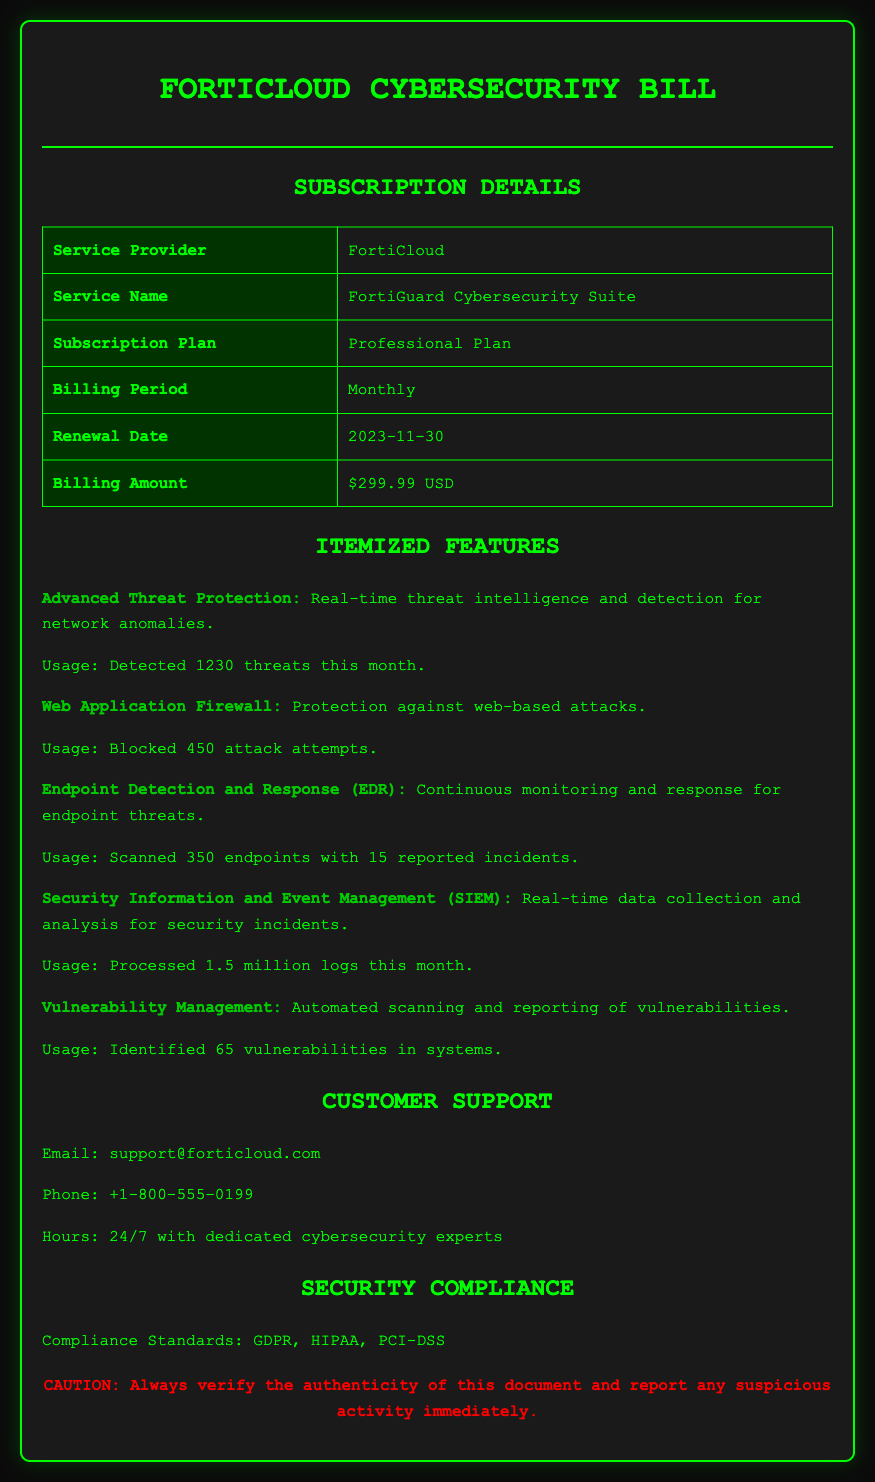What is the service provider? The document clearly states that the service provider is FortiCloud.
Answer: FortiCloud What is the subscription plan? The subscription plan is specified in the document as the Professional Plan.
Answer: Professional Plan When is the renewal date? The renewal date for the subscription is mentioned in the document as November 30, 2023.
Answer: 2023-11-30 How much is the monthly billing amount? The monthly billing amount is listed in the document as $299.99 USD.
Answer: $299.99 USD How many threats were detected this month? The document indicates that 1230 threats were detected within the month under the Advanced Threat Protection feature.
Answer: 1230 What compliance standards are listed? The document mentions compliance standards, which include GDPR, HIPAA, and PCI-DSS.
Answer: GDPR, HIPAA, PCI-DSS What is the usage for the Web Application Firewall? The document states that the Web Application Firewall blocked 450 attack attempts this month.
Answer: Blocked 450 attack attempts What type of document is this? The document is identified as a monthly subscription bill for a cloud-based cybersecurity software service.
Answer: Monthly subscription bill How many vulnerabilities were identified in systems? According to the document, a total of 65 vulnerabilities were identified in the systems.
Answer: 65 